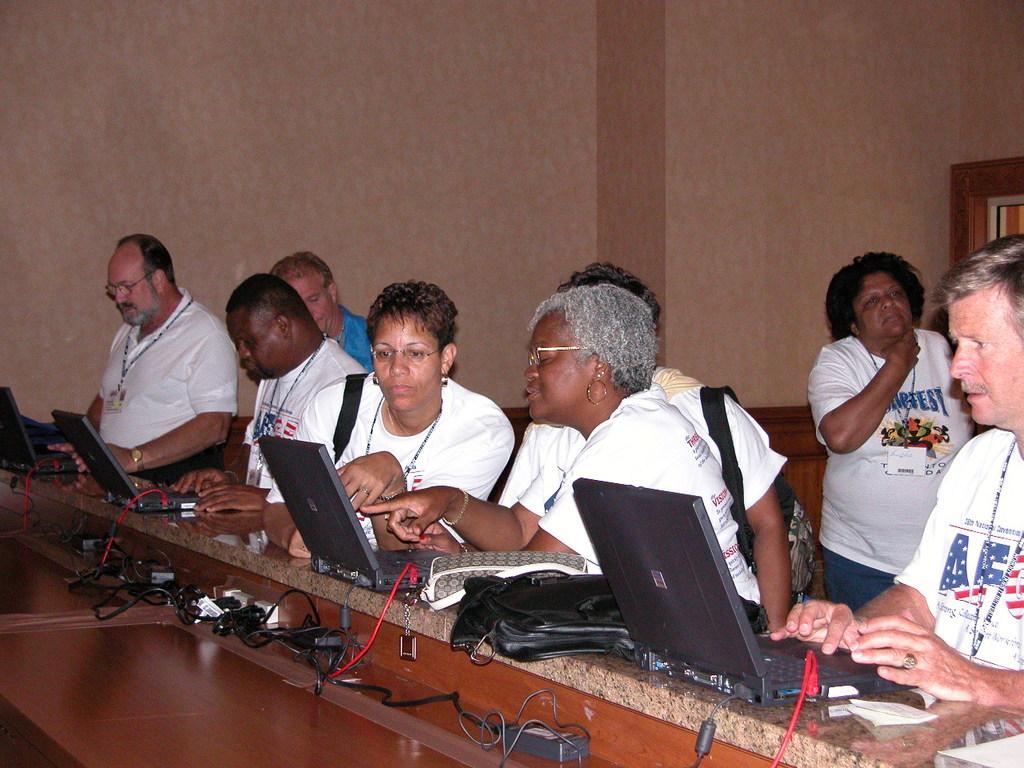Can you describe this image briefly? In this picture we can see a group of people standing where some are carrying bags and in front of them we can see laptops and wires on a platform and in the background we can see the wall. 